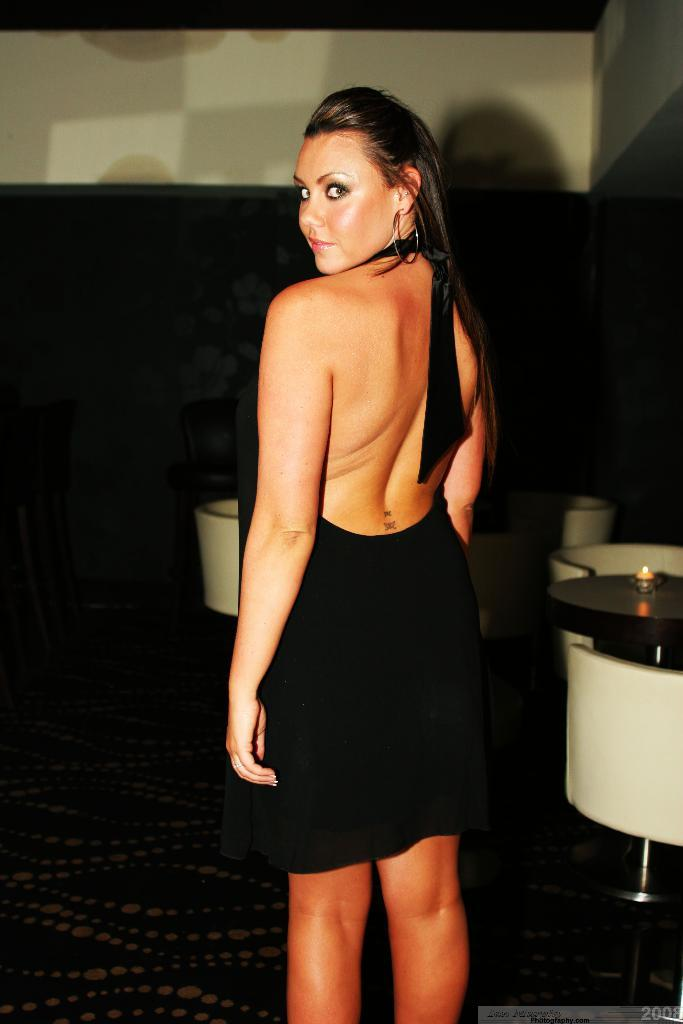Who is present in the image? There is a woman in the image. What is the woman doing in the image? The woman is standing and posing. What is the woman wearing in the image? The woman is wearing a black dress. What furniture can be seen in the image? There are chairs and a table in the image. What object is on the table in the image? There is a candle on the table. What type of birds can be seen flying around the woman in the image? There are no birds present in the image. What type of punishment is the woman receiving in the image? There is no indication of punishment in the image; the woman is standing and posing. 